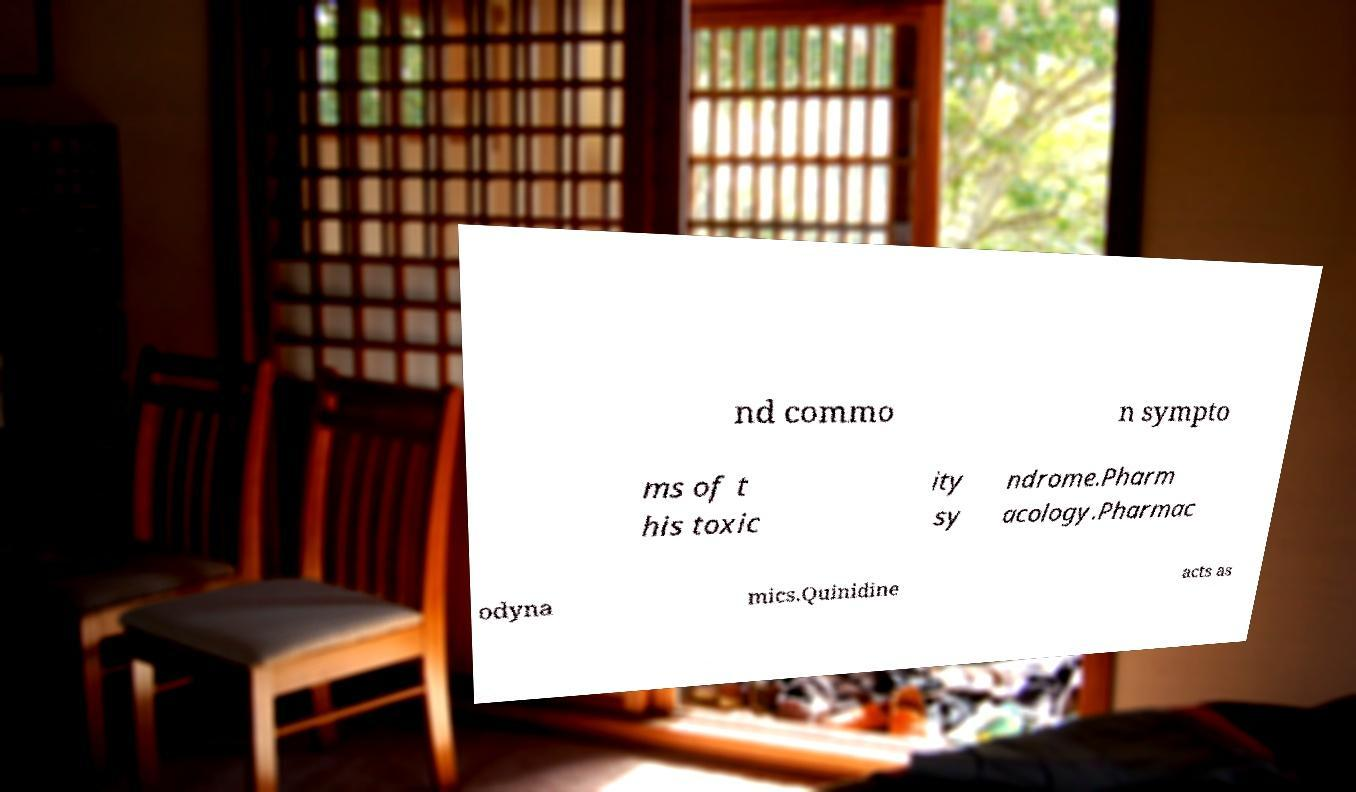There's text embedded in this image that I need extracted. Can you transcribe it verbatim? nd commo n sympto ms of t his toxic ity sy ndrome.Pharm acology.Pharmac odyna mics.Quinidine acts as 